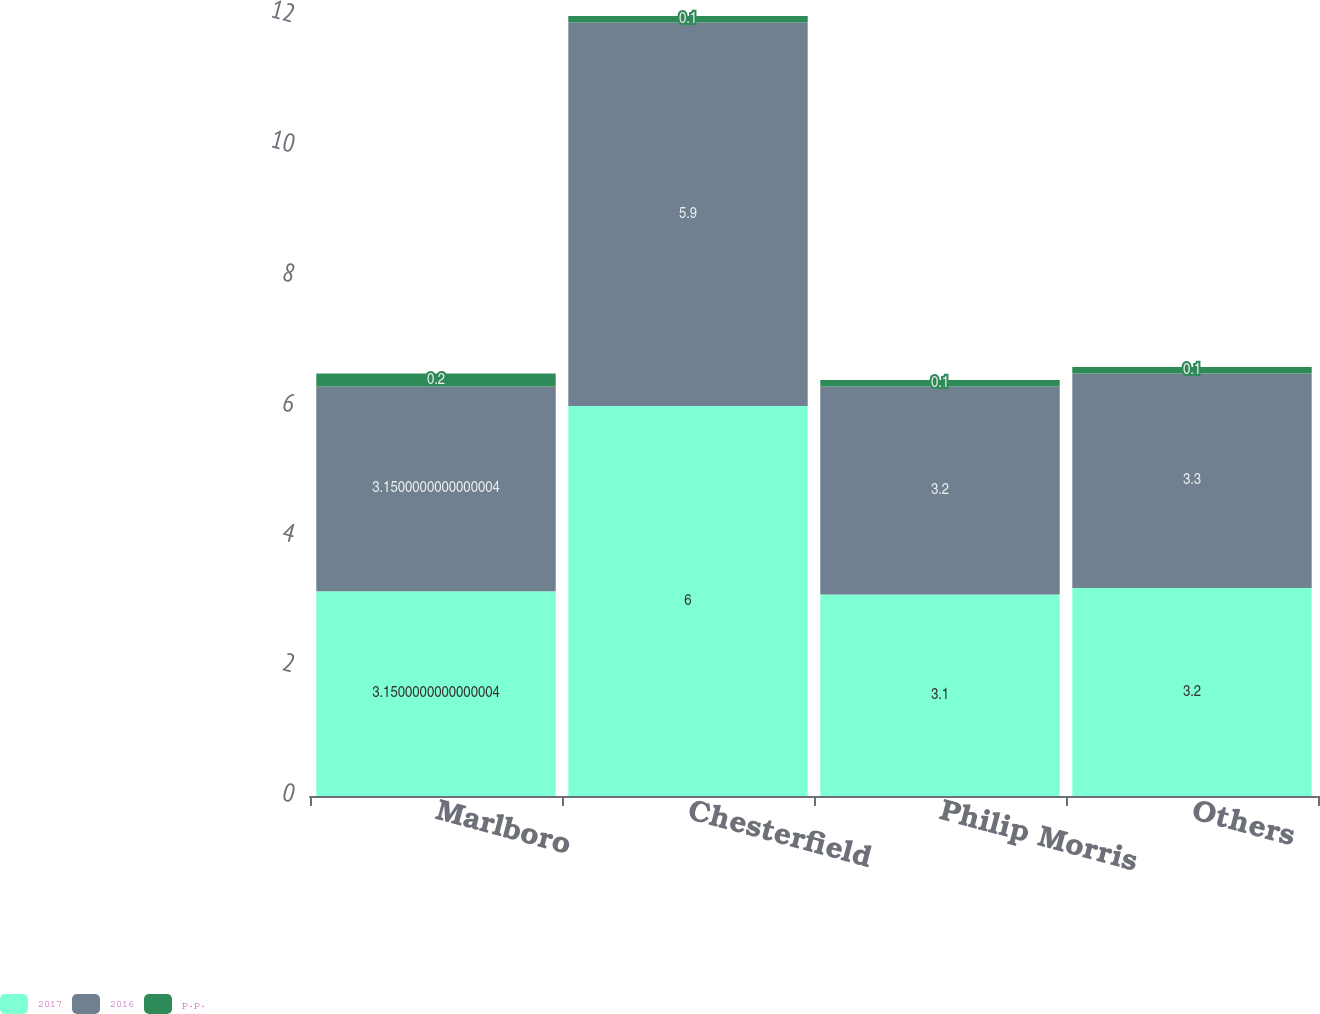Convert chart to OTSL. <chart><loc_0><loc_0><loc_500><loc_500><stacked_bar_chart><ecel><fcel>Marlboro<fcel>Chesterfield<fcel>Philip Morris<fcel>Others<nl><fcel>2017<fcel>3.15<fcel>6<fcel>3.1<fcel>3.2<nl><fcel>2016<fcel>3.15<fcel>5.9<fcel>3.2<fcel>3.3<nl><fcel>p.p.<fcel>0.2<fcel>0.1<fcel>0.1<fcel>0.1<nl></chart> 